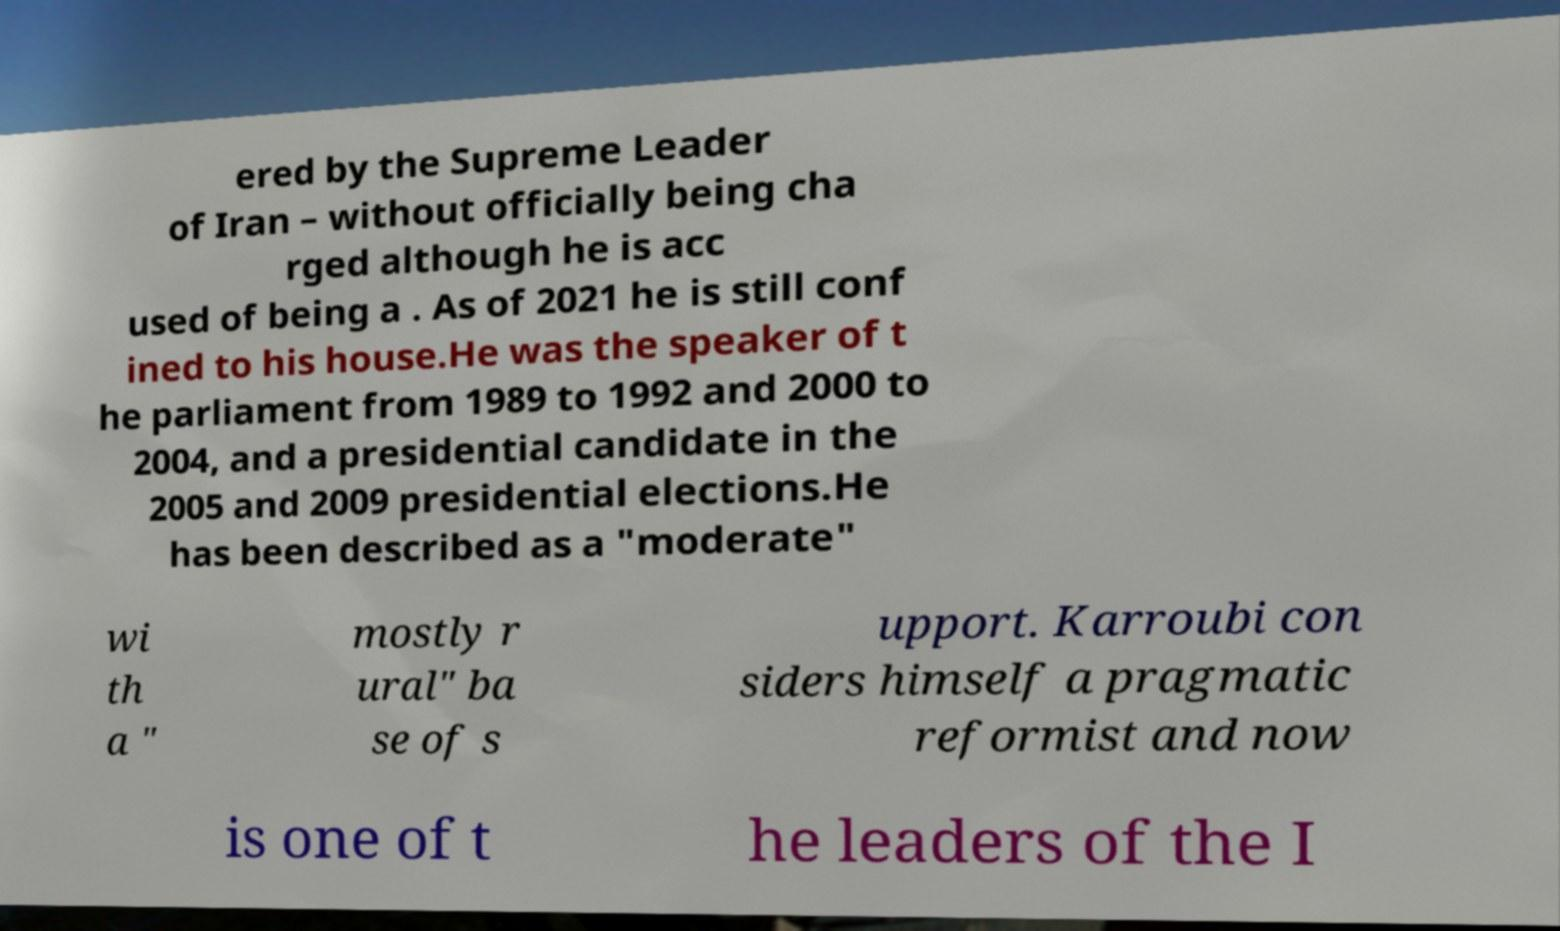Can you accurately transcribe the text from the provided image for me? ered by the Supreme Leader of Iran – without officially being cha rged although he is acc used of being a . As of 2021 he is still conf ined to his house.He was the speaker of t he parliament from 1989 to 1992 and 2000 to 2004, and a presidential candidate in the 2005 and 2009 presidential elections.He has been described as a "moderate" wi th a " mostly r ural" ba se of s upport. Karroubi con siders himself a pragmatic reformist and now is one of t he leaders of the I 